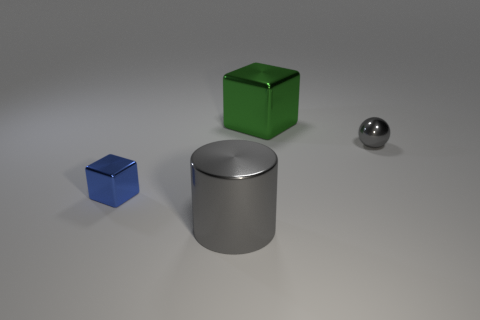There is a large metallic object behind the metallic object in front of the blue metallic block; what is its color?
Make the answer very short. Green. Are there any other things that are the same shape as the big gray object?
Your response must be concise. No. Are there an equal number of tiny metal spheres that are in front of the small block and small metallic cubes that are to the right of the green metal cube?
Your answer should be compact. Yes. What number of spheres are large blue rubber objects or tiny gray metallic things?
Your answer should be compact. 1. What number of other objects are there of the same material as the small blue thing?
Your answer should be compact. 3. There is a gray thing that is behind the large gray shiny cylinder; what is its shape?
Ensure brevity in your answer.  Sphere. Are there more gray objects to the right of the gray cylinder than large brown shiny cylinders?
Provide a short and direct response. Yes. How many other objects are there of the same color as the sphere?
Offer a terse response. 1. The gray shiny object that is the same size as the green block is what shape?
Make the answer very short. Cylinder. There is a block behind the metal thing to the left of the large cylinder; how many small metallic spheres are left of it?
Offer a very short reply. 0. 